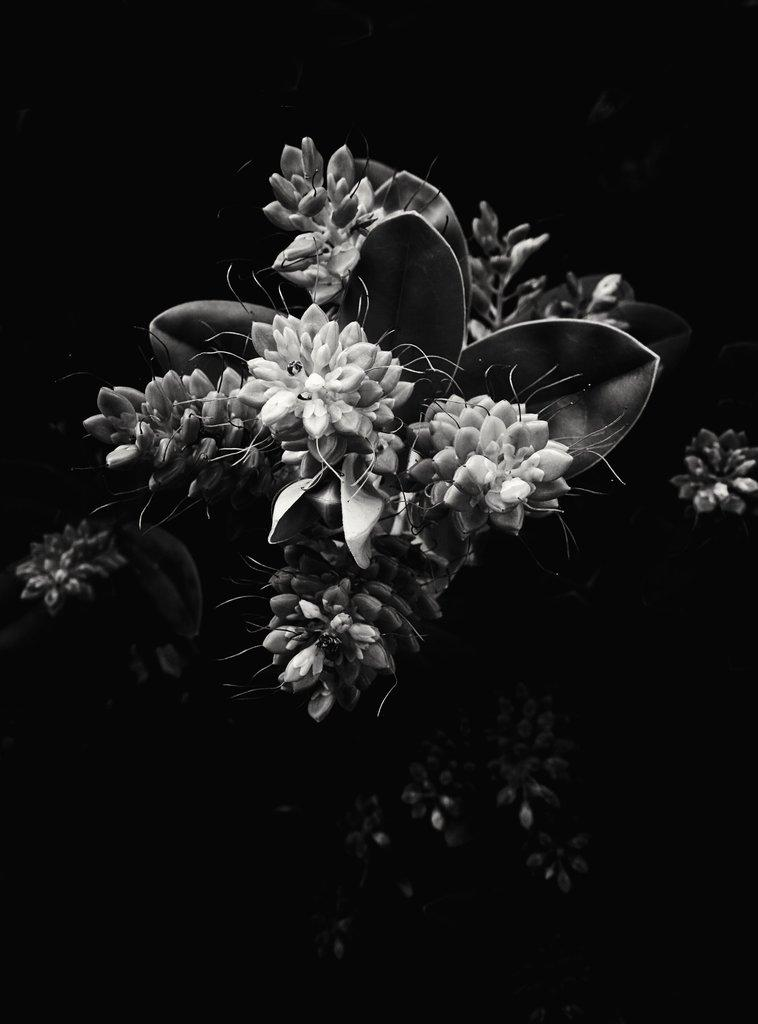What is the color scheme of the image? The image is black and white. What is the main subject in the middle of the image? There are flowers in the middle of the image. What else can be seen under the flowers in the image? There are leaves under the flowers in the image. What type of reaction can be seen from the apple in the image? There is no apple present in the image, so it is not possible to determine any reaction. 